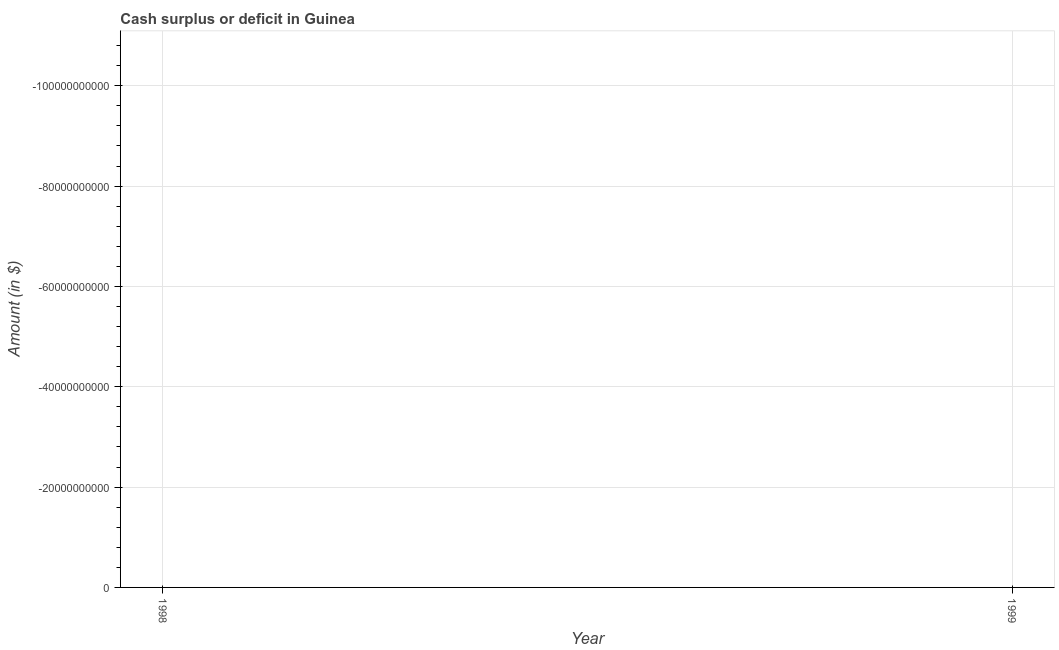Across all years, what is the minimum cash surplus or deficit?
Offer a terse response. 0. What is the average cash surplus or deficit per year?
Provide a succinct answer. 0. What is the median cash surplus or deficit?
Give a very brief answer. 0. How many lines are there?
Provide a short and direct response. 0. How many years are there in the graph?
Make the answer very short. 2. What is the difference between two consecutive major ticks on the Y-axis?
Give a very brief answer. 2.00e+1. Are the values on the major ticks of Y-axis written in scientific E-notation?
Your answer should be very brief. No. Does the graph contain grids?
Keep it short and to the point. Yes. What is the title of the graph?
Your answer should be very brief. Cash surplus or deficit in Guinea. What is the label or title of the X-axis?
Your answer should be very brief. Year. What is the label or title of the Y-axis?
Give a very brief answer. Amount (in $). What is the Amount (in $) of 1999?
Your answer should be very brief. 0. 